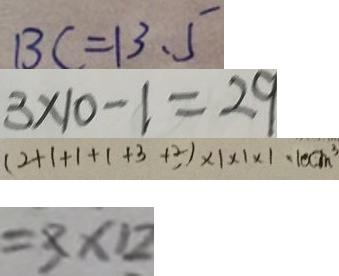Convert formula to latex. <formula><loc_0><loc_0><loc_500><loc_500>B C = 1 3 . 5 
 3 \times 1 0 - 1 = 2 9 
 ( 2 + 1 + 1 + 1 + 3 + 2 , ) \times 1 \times 1 \times 1 \cdot 1 0 c m ^ { 3 } 
 = 3 \times 1 2</formula> 